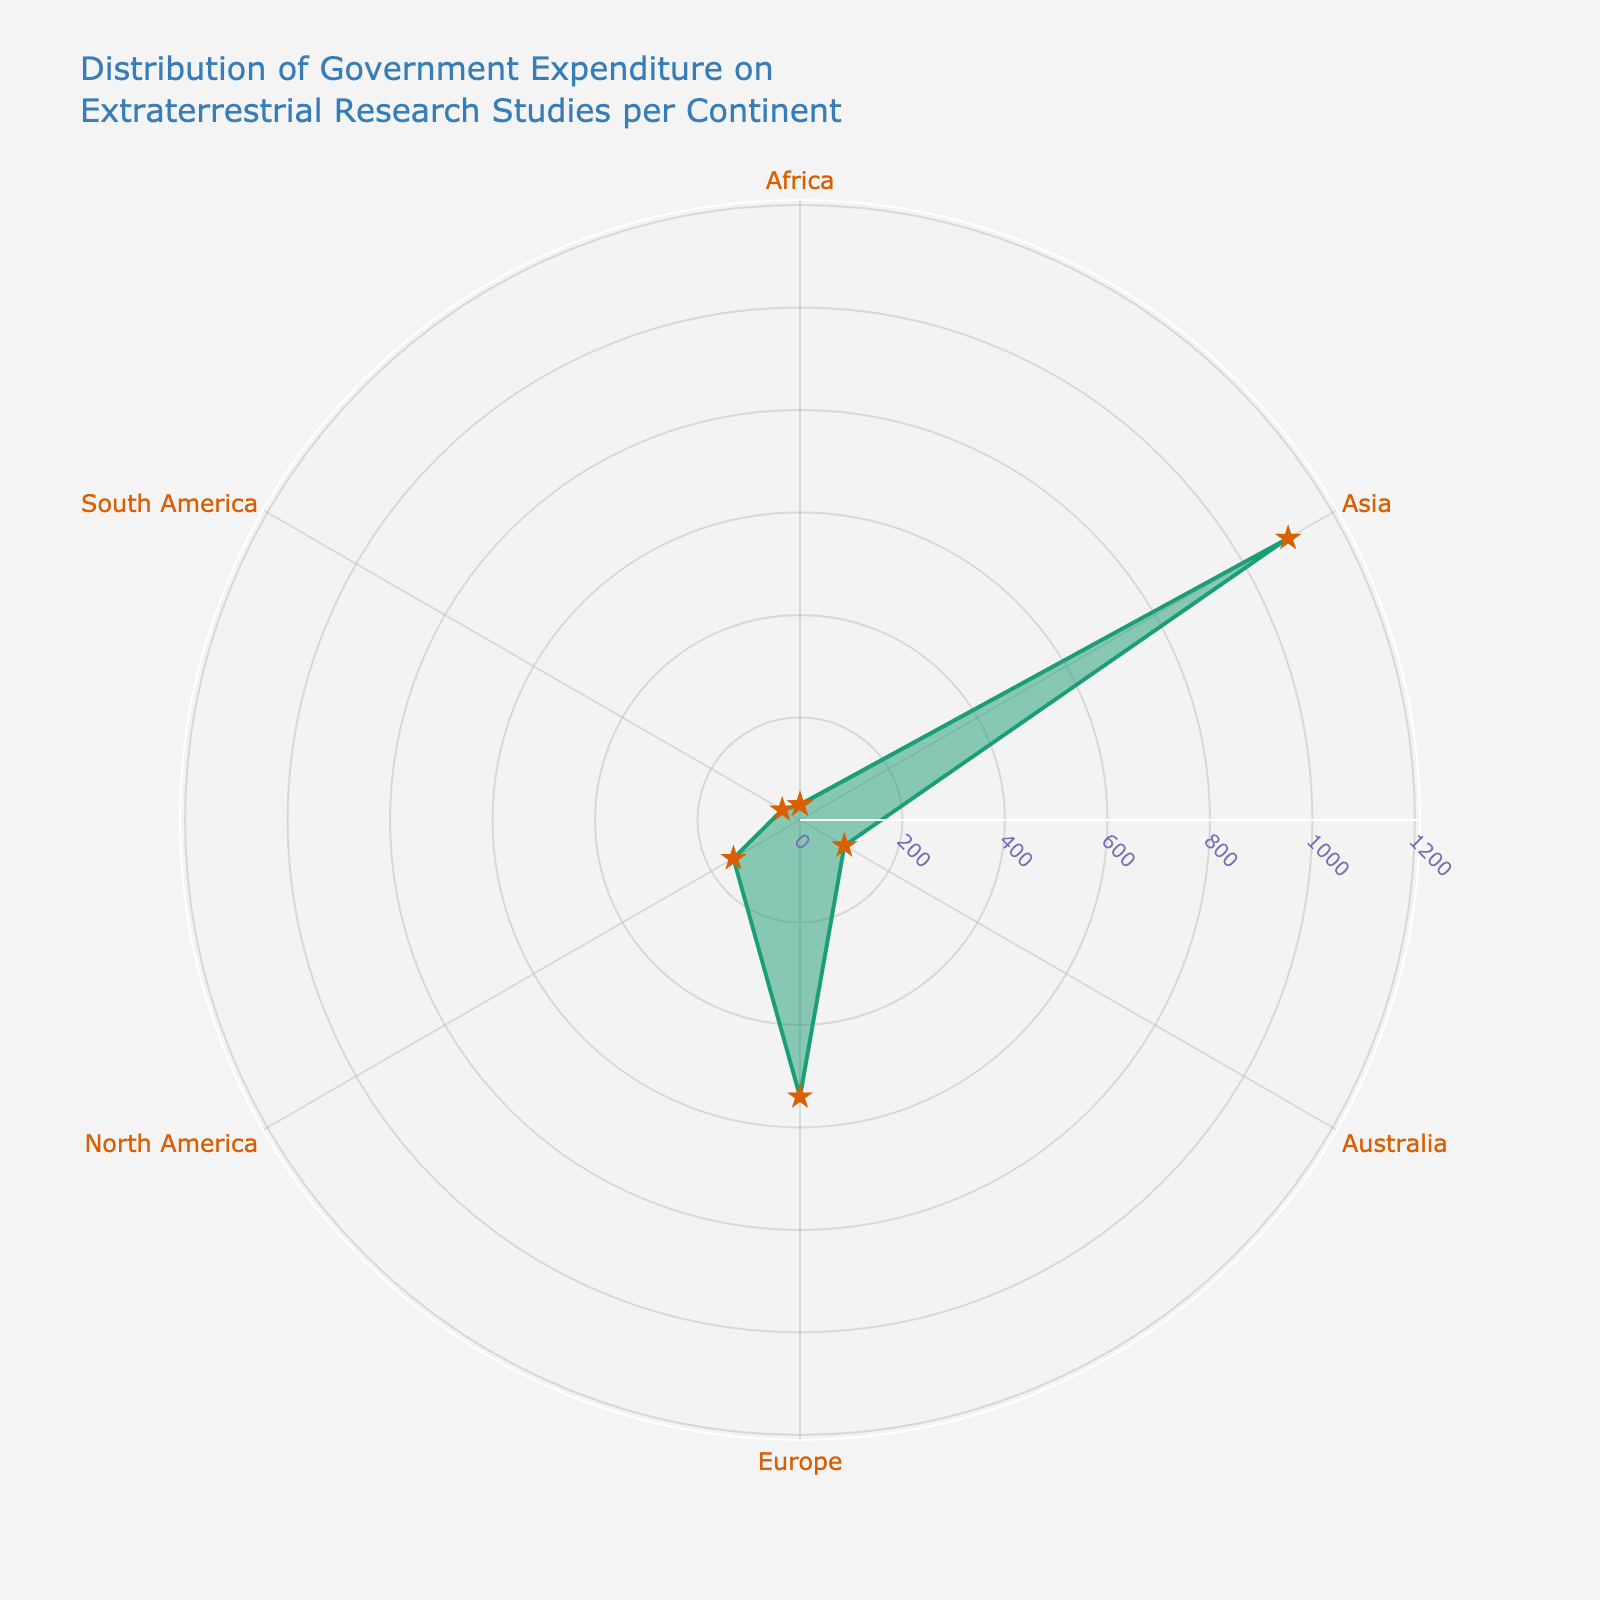What's the title of the polar chart? The title is displayed prominently at the top of the chart. It reads, 'Distribution of Government Expenditure on Extraterrestrial Research Studies per Continent'.
Answer: Distribution of Government Expenditure on Extraterrestrial Research Studies per Continent How many continents are represented in the chart? Each continent corresponds to a named axis on the polar chart edges. Counting all the labels gives us six continents.
Answer: Six Which continent has the highest government expenditure on extraterrestrial research studies? The radial axis indicates government expenditure, and the length of the radius determines the value. Asia has the longest radius, indicating the highest expenditure.
Answer: Asia What's the government expenditure for Europe? Find the value on the radial axis labeled 'Europe'. The radial length shows a value of 540 million USD.
Answer: 540 million USD Which continent has the least government expenditure, and what is the value? The radial length for each continent shows the expenditure. Africa has the shortest radius, indicating the least expenditure of 30 million USD.
Answer: Africa, 30 million USD What's the combined expenditure of Asia and North America? The radial lengths show the values for Asia (1100 million USD) and North America (150 million USD). Summing them up gives 1250 million USD.
Answer: 1250 million USD How does the expenditure for South America compare to Australia? Look at the radial lengths for South America and Australia. Australia has 100 million USD, while South America has 40 million USD, indicating Australia has more.
Answer: Australia has more Is there any continent with government expenditure between 200 and 500 million USD? The chart shows each continent's expenditure. North America has 150 million, Europe has 540 million, Asia has 1100 million, Australia has 100 million, South America has 40 million, and Africa has 30 million. None fall between 200 and 500 million USD.
Answer: No What is the second highest expenditure among the continents? Sort the expenditures visually. Asia has the highest with 1100 million USD. The next longest radius is Europe, with 540 million USD.
Answer: Europe 540 million USD Calculate the average expenditure across all continents. Sum all expenditures and divide by the number of continents: (150 + 540 + 1100 + 100 + 40 + 30) / 6 = 1960 / 6 = 326.67 million USD.
Answer: 326.67 million USD 